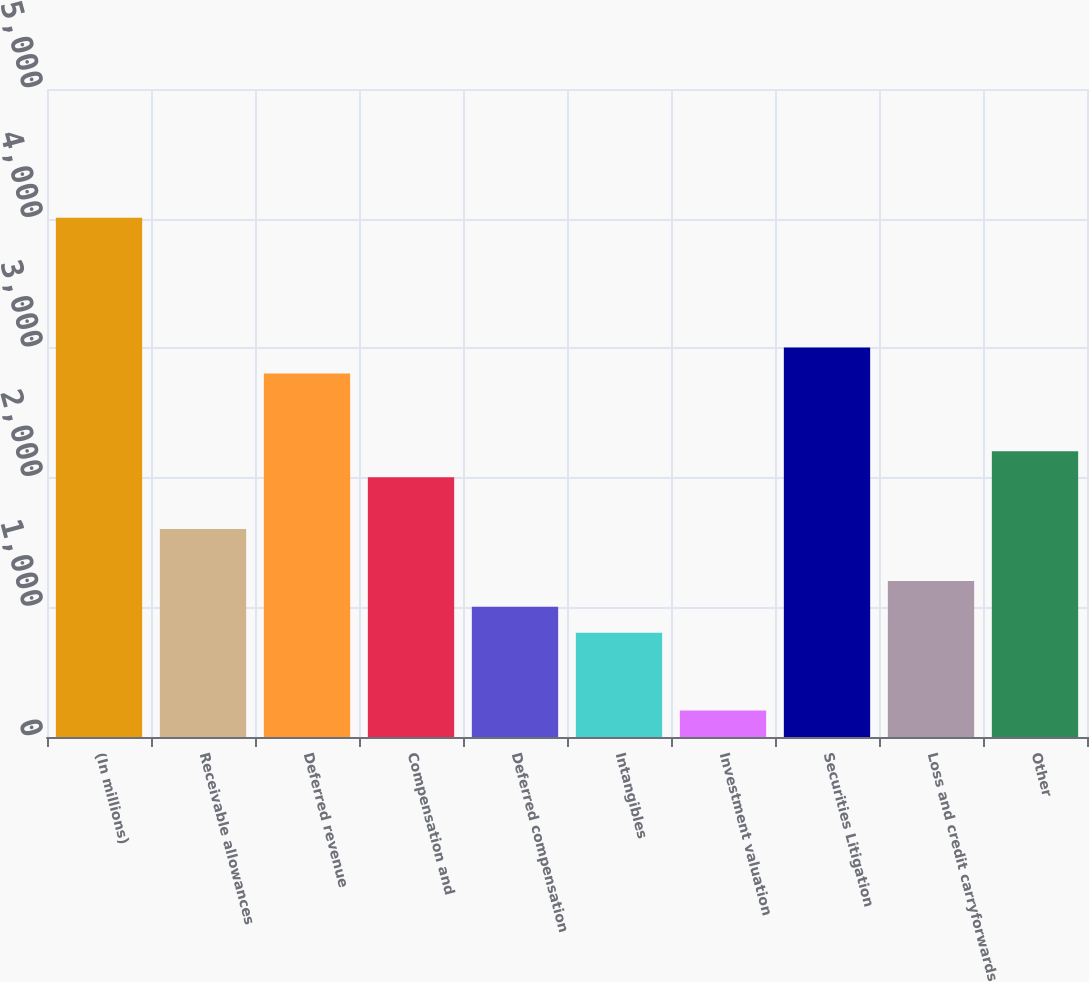<chart> <loc_0><loc_0><loc_500><loc_500><bar_chart><fcel>(In millions)<fcel>Receivable allowances<fcel>Deferred revenue<fcel>Compensation and<fcel>Deferred compensation<fcel>Intangibles<fcel>Investment valuation<fcel>Securities Litigation<fcel>Loss and credit carryforwards<fcel>Other<nl><fcel>4006<fcel>1604.8<fcel>2805.4<fcel>2005<fcel>1004.5<fcel>804.4<fcel>204.1<fcel>3005.5<fcel>1204.6<fcel>2205.1<nl></chart> 